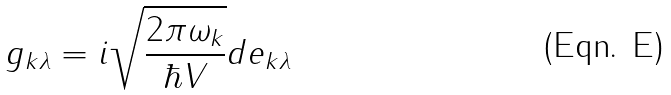<formula> <loc_0><loc_0><loc_500><loc_500>g _ { { k } \lambda } = i \sqrt { \frac { 2 \pi \omega _ { k } } { \hbar { V } } } { d } { e } _ { { k } \lambda }</formula> 